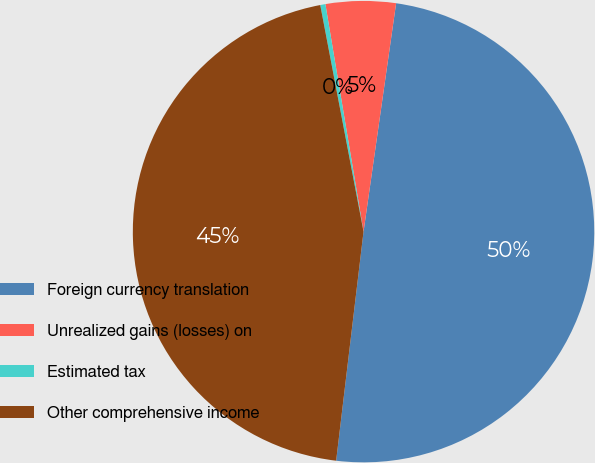Convert chart to OTSL. <chart><loc_0><loc_0><loc_500><loc_500><pie_chart><fcel>Foreign currency translation<fcel>Unrealized gains (losses) on<fcel>Estimated tax<fcel>Other comprehensive income<nl><fcel>49.64%<fcel>4.9%<fcel>0.36%<fcel>45.1%<nl></chart> 